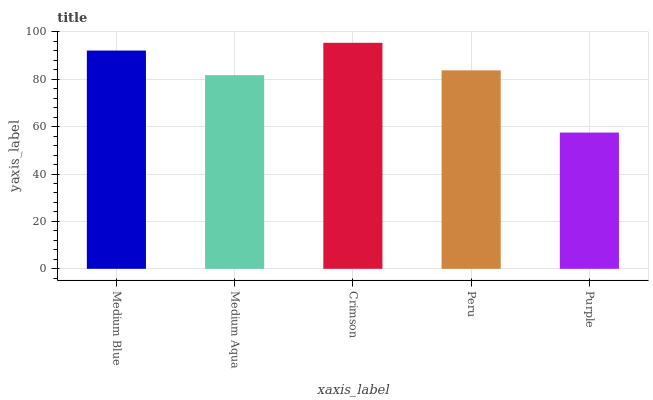Is Purple the minimum?
Answer yes or no. Yes. Is Crimson the maximum?
Answer yes or no. Yes. Is Medium Aqua the minimum?
Answer yes or no. No. Is Medium Aqua the maximum?
Answer yes or no. No. Is Medium Blue greater than Medium Aqua?
Answer yes or no. Yes. Is Medium Aqua less than Medium Blue?
Answer yes or no. Yes. Is Medium Aqua greater than Medium Blue?
Answer yes or no. No. Is Medium Blue less than Medium Aqua?
Answer yes or no. No. Is Peru the high median?
Answer yes or no. Yes. Is Peru the low median?
Answer yes or no. Yes. Is Purple the high median?
Answer yes or no. No. Is Purple the low median?
Answer yes or no. No. 